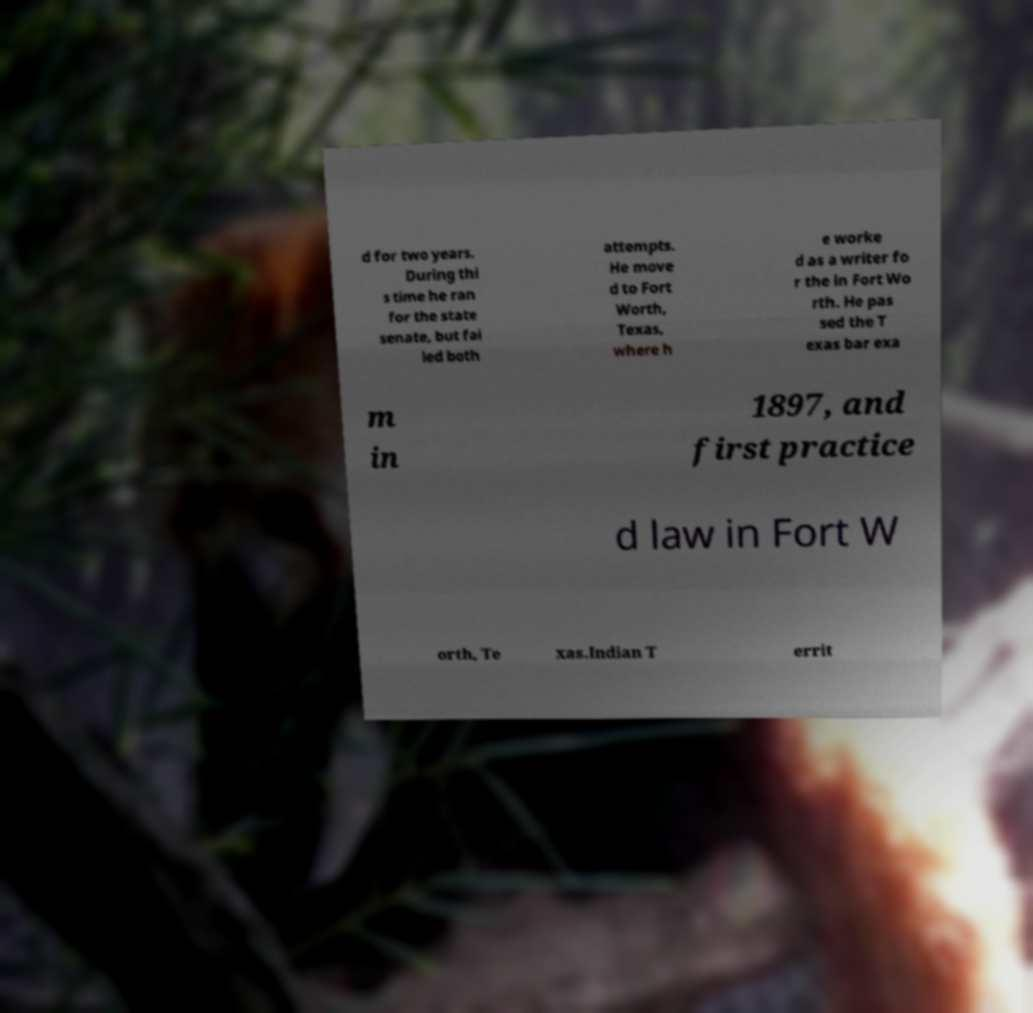For documentation purposes, I need the text within this image transcribed. Could you provide that? d for two years. During thi s time he ran for the state senate, but fai led both attempts. He move d to Fort Worth, Texas, where h e worke d as a writer fo r the in Fort Wo rth. He pas sed the T exas bar exa m in 1897, and first practice d law in Fort W orth, Te xas.Indian T errit 